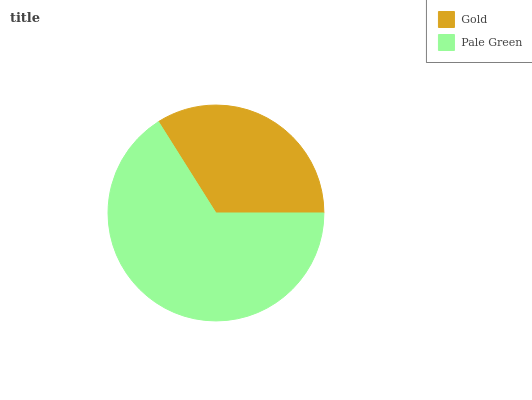Is Gold the minimum?
Answer yes or no. Yes. Is Pale Green the maximum?
Answer yes or no. Yes. Is Pale Green the minimum?
Answer yes or no. No. Is Pale Green greater than Gold?
Answer yes or no. Yes. Is Gold less than Pale Green?
Answer yes or no. Yes. Is Gold greater than Pale Green?
Answer yes or no. No. Is Pale Green less than Gold?
Answer yes or no. No. Is Pale Green the high median?
Answer yes or no. Yes. Is Gold the low median?
Answer yes or no. Yes. Is Gold the high median?
Answer yes or no. No. Is Pale Green the low median?
Answer yes or no. No. 